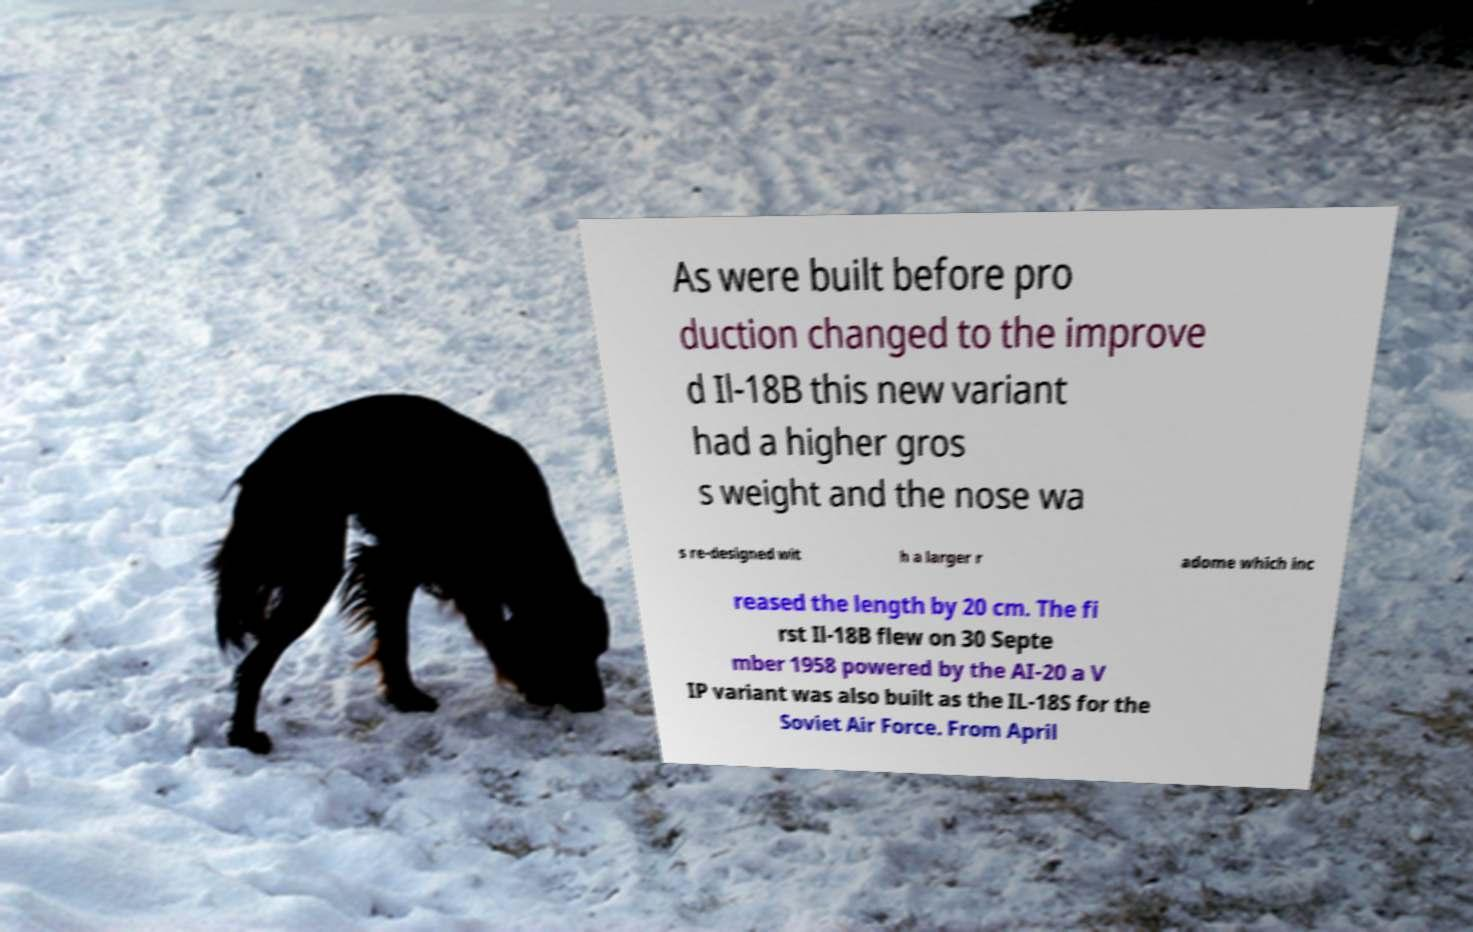Could you extract and type out the text from this image? As were built before pro duction changed to the improve d Il-18B this new variant had a higher gros s weight and the nose wa s re-designed wit h a larger r adome which inc reased the length by 20 cm. The fi rst Il-18B flew on 30 Septe mber 1958 powered by the AI-20 a V IP variant was also built as the IL-18S for the Soviet Air Force. From April 